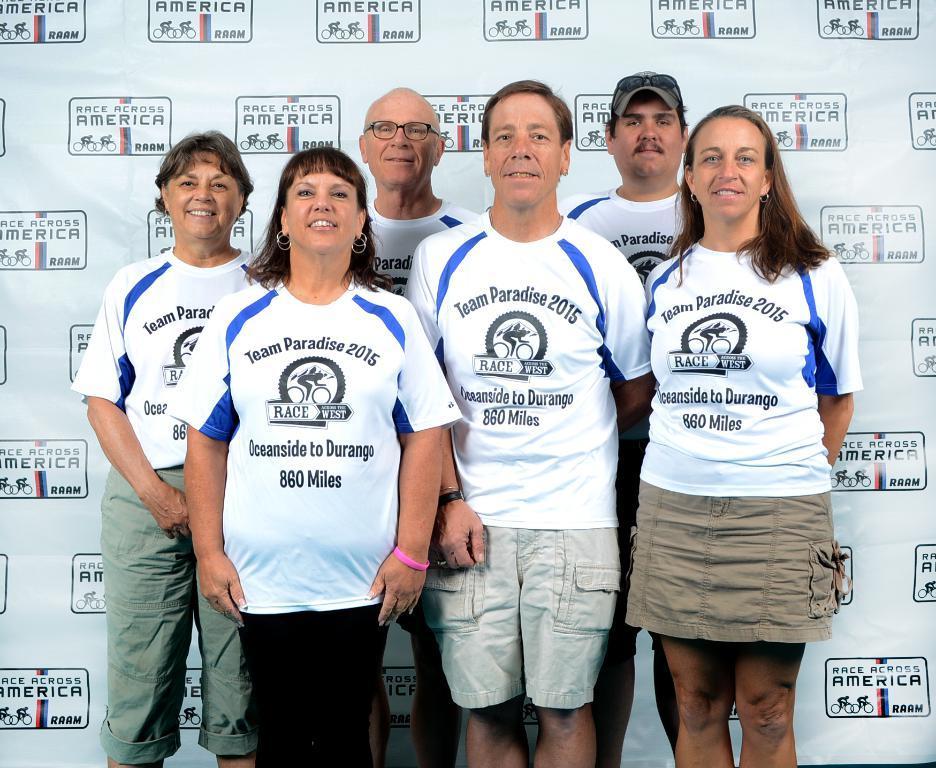Could you give a brief overview of what you see in this image? In this image there are a few people standing with a smile on their face, behind him there is a banner with some text. 